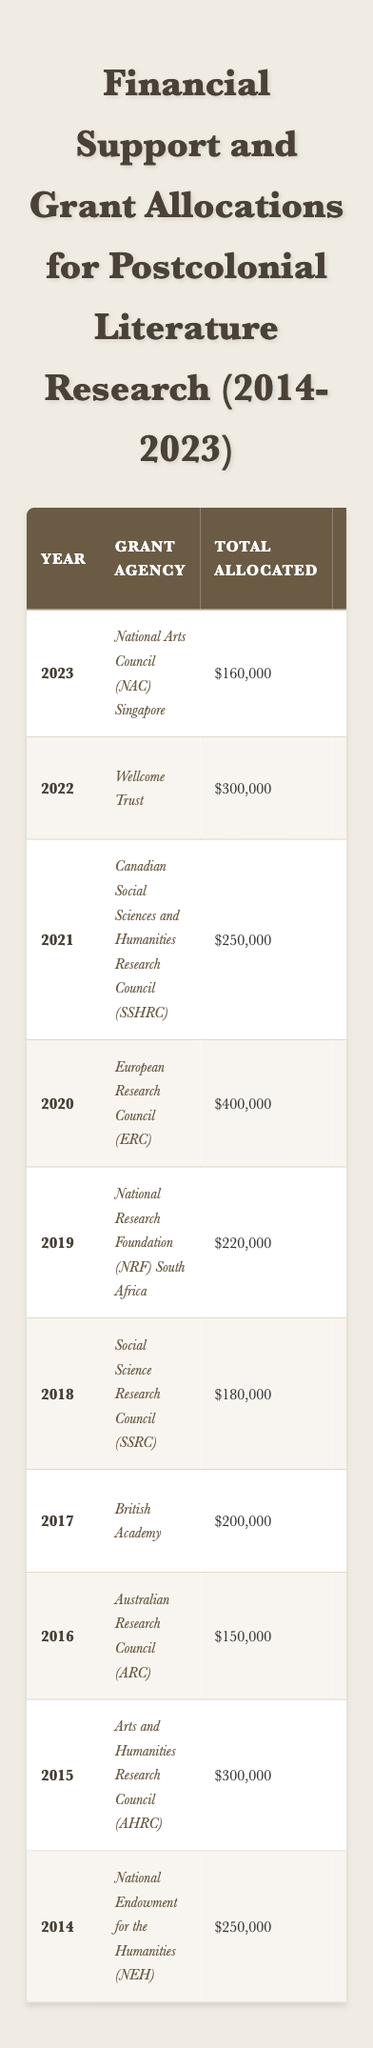What was the total amount allocated for grants in 2022? In the row for 2022, the table shows that the total allocated amount was $300,000.
Answer: $300,000 How many grants were awarded in 2019? According to the data for 2019, the number of grants awarded was 4.
Answer: 4 What is the average grant amount for 2015? The average grant amount for 2015 is displayed as $42,857, obtained by dividing the total allocated ($300,000) by the number of grants (7).
Answer: $42,857 Which grant agency provided funding for studies on "Transnational Studies in Postcolonial Contexts"? The table shows that the European Research Council (ERC) in 2020 focused on "Transnational Studies in Postcolonial Contexts."
Answer: European Research Council (ERC) Did the total allocatd amount for grants increase from 2018 to 2019? The total allocated amount for 2018 was $180,000, and for 2019, it was $220,000, indicating an increase of $40,000.
Answer: Yes What was the average grant amount across all years in the table? To find the average, first sum all total allocated amounts: (250000 + 300000 + 150000 + 200000 + 180000 + 220000 + 400000 + 250000 + 300000 + 160000) = 2240000. There are 10 years, so dividing gives 2240000/10 = 224000.
Answer: $224,000 Which year had the highest total allocated amount and what was it? By reviewing the total allocated amounts from each year, we see that 2020 had the highest allocation, which was $400,000.
Answer: 2020, $400,000 How many grants were focused on "Health and Postcolonial Literature" in 2022 compared to the total number of grants that year? The number of grants focused on "Health and Postcolonial Literature" in 2022 was 6. This was also the total number of grants awarded that year, showing all grants were focused in that area.
Answer: 6 Calculate the difference in average grant amounts between 2020 and 2023. For 2020, the average grant amount was $50,000, and for 2023, it was $40,000. The difference is calculated as $50,000 - $40,000 = $10,000.
Answer: $10,000 Which grant agency awarded the least total amount, and how much was that? The Australian Research Council (ARC) awarded the least amount at $150,000 in 2016.
Answer: Australian Research Council (ARC), $150,000 Was there any year where the average grant amount was below $30,000? Looking at the average grant amounts, the only year where it fell below $30,000 was 2018 with an average of $30,000.
Answer: No 